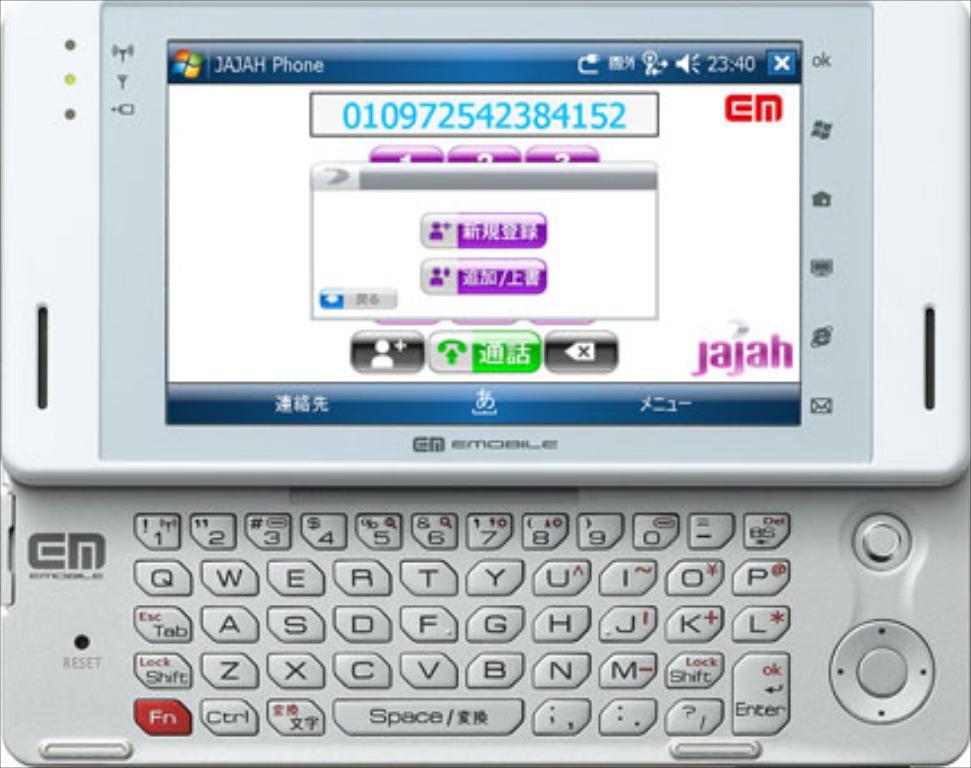What is the word that starts with a "j" on this phone?
Give a very brief answer. Jajah. What kind of phone?
Give a very brief answer. Jajah. 